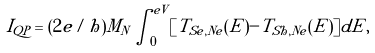<formula> <loc_0><loc_0><loc_500><loc_500>I _ { Q P } = ( 2 e / h ) M _ { N } \int ^ { e V } _ { 0 } [ T _ { S e , N e } ( E ) - T _ { S h , N e } ( E ) ] d E ,</formula> 